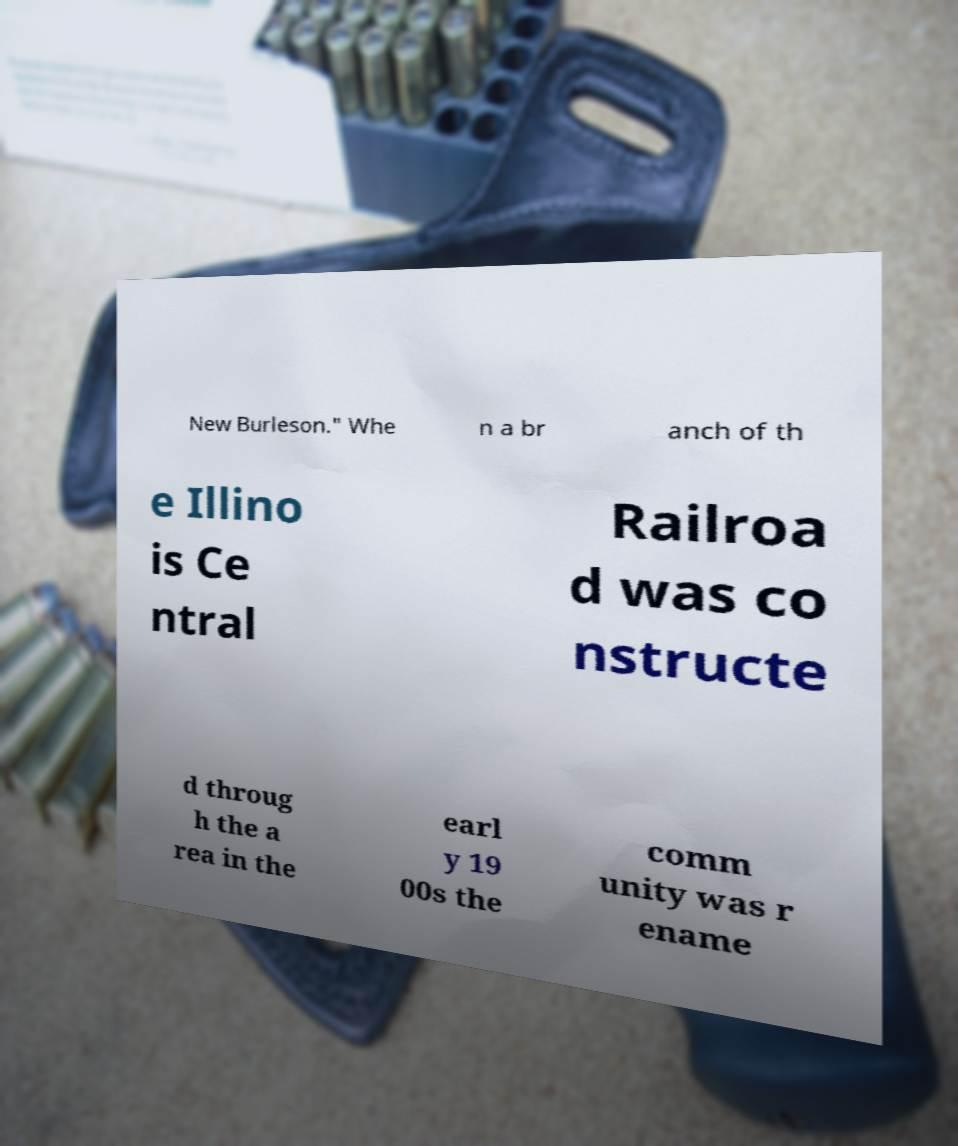I need the written content from this picture converted into text. Can you do that? New Burleson." Whe n a br anch of th e Illino is Ce ntral Railroa d was co nstructe d throug h the a rea in the earl y 19 00s the comm unity was r ename 